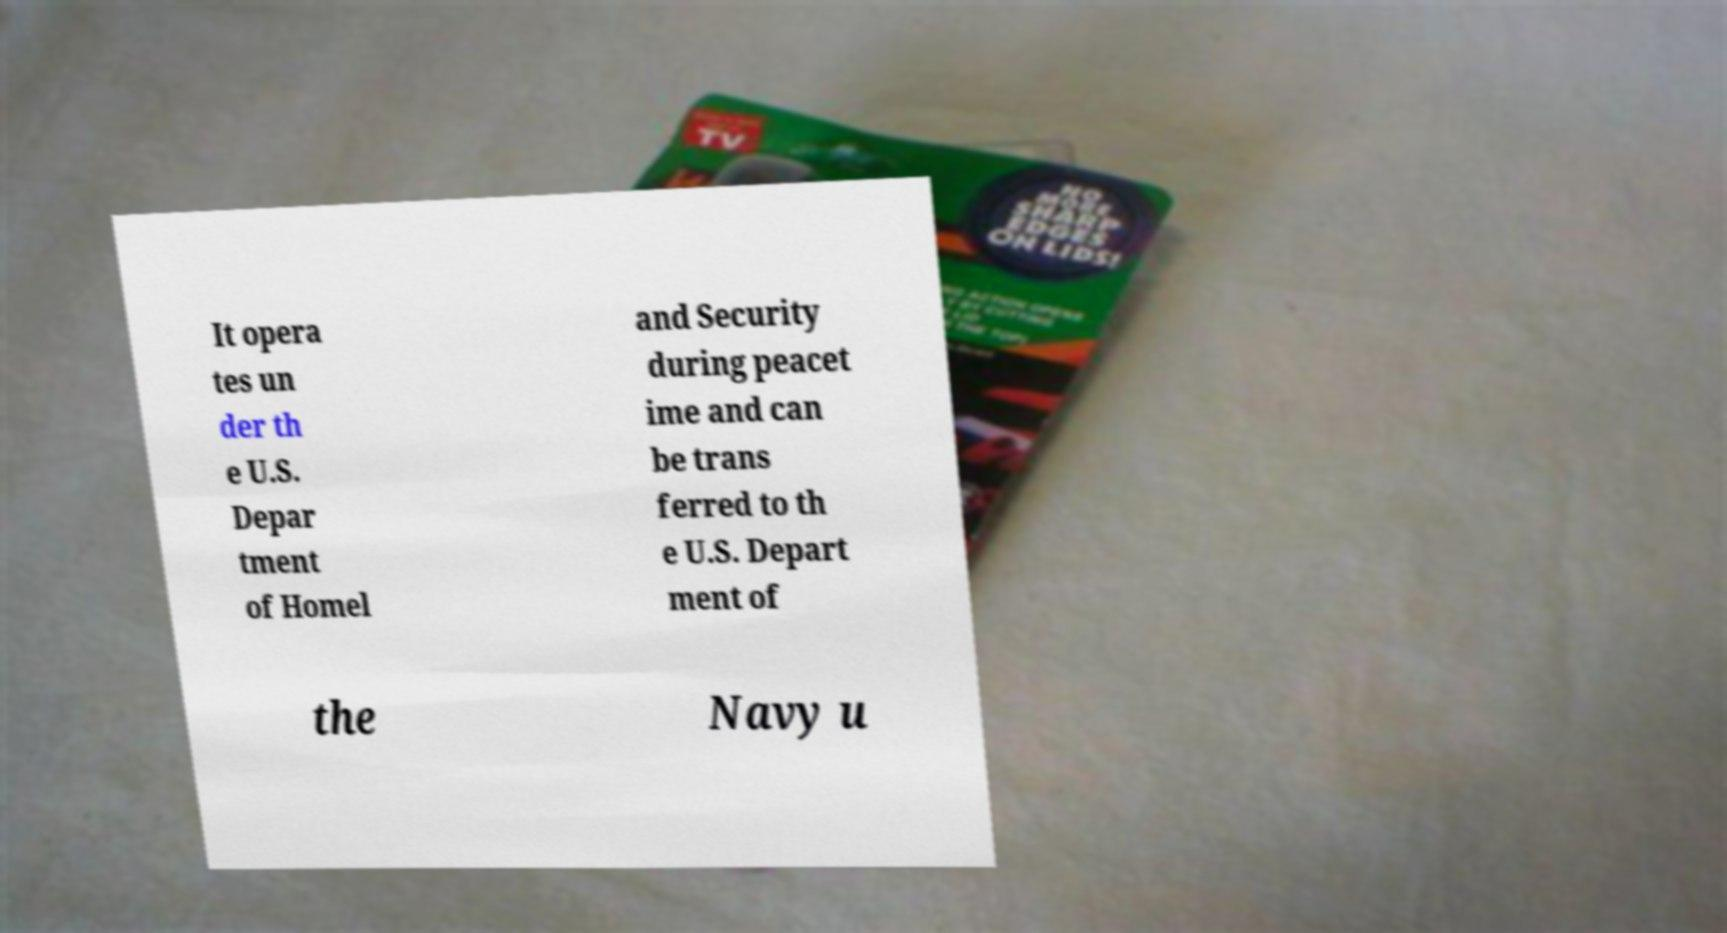Can you accurately transcribe the text from the provided image for me? It opera tes un der th e U.S. Depar tment of Homel and Security during peacet ime and can be trans ferred to th e U.S. Depart ment of the Navy u 